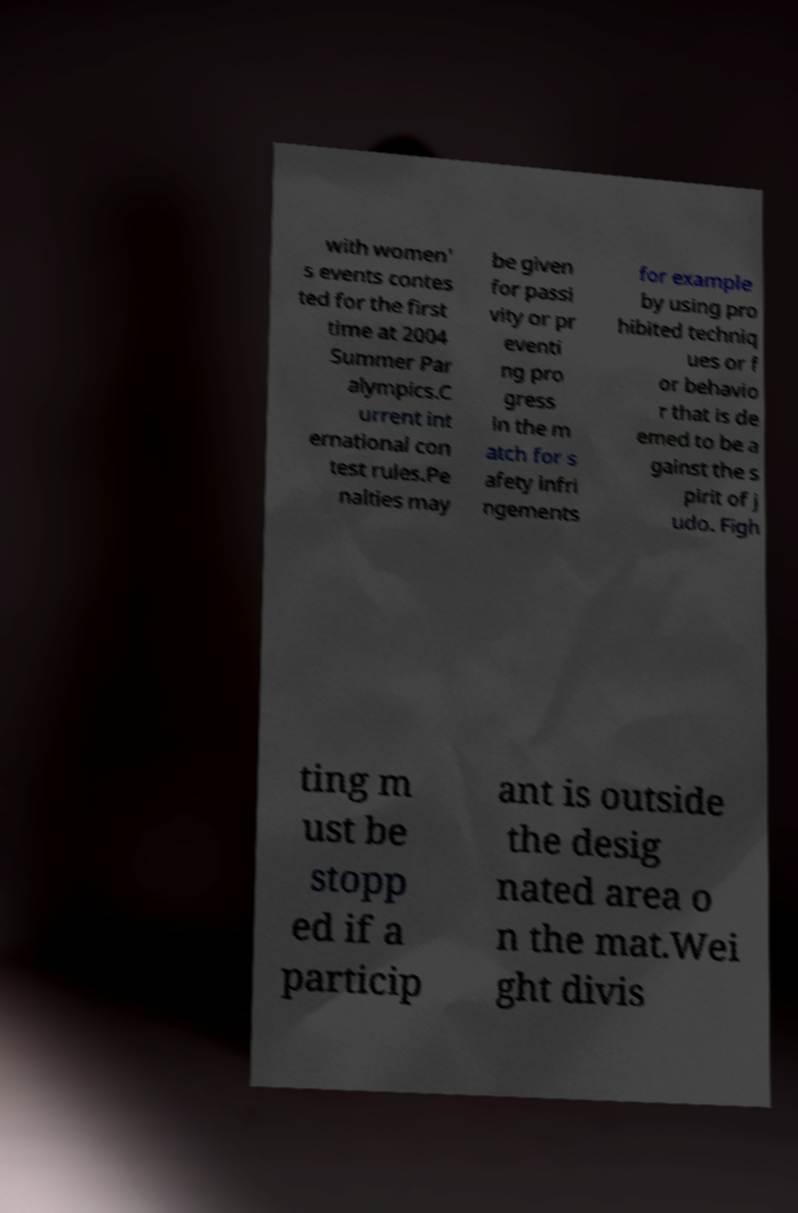Please read and relay the text visible in this image. What does it say? with women' s events contes ted for the first time at 2004 Summer Par alympics.C urrent int ernational con test rules.Pe nalties may be given for passi vity or pr eventi ng pro gress in the m atch for s afety infri ngements for example by using pro hibited techniq ues or f or behavio r that is de emed to be a gainst the s pirit of j udo. Figh ting m ust be stopp ed if a particip ant is outside the desig nated area o n the mat.Wei ght divis 